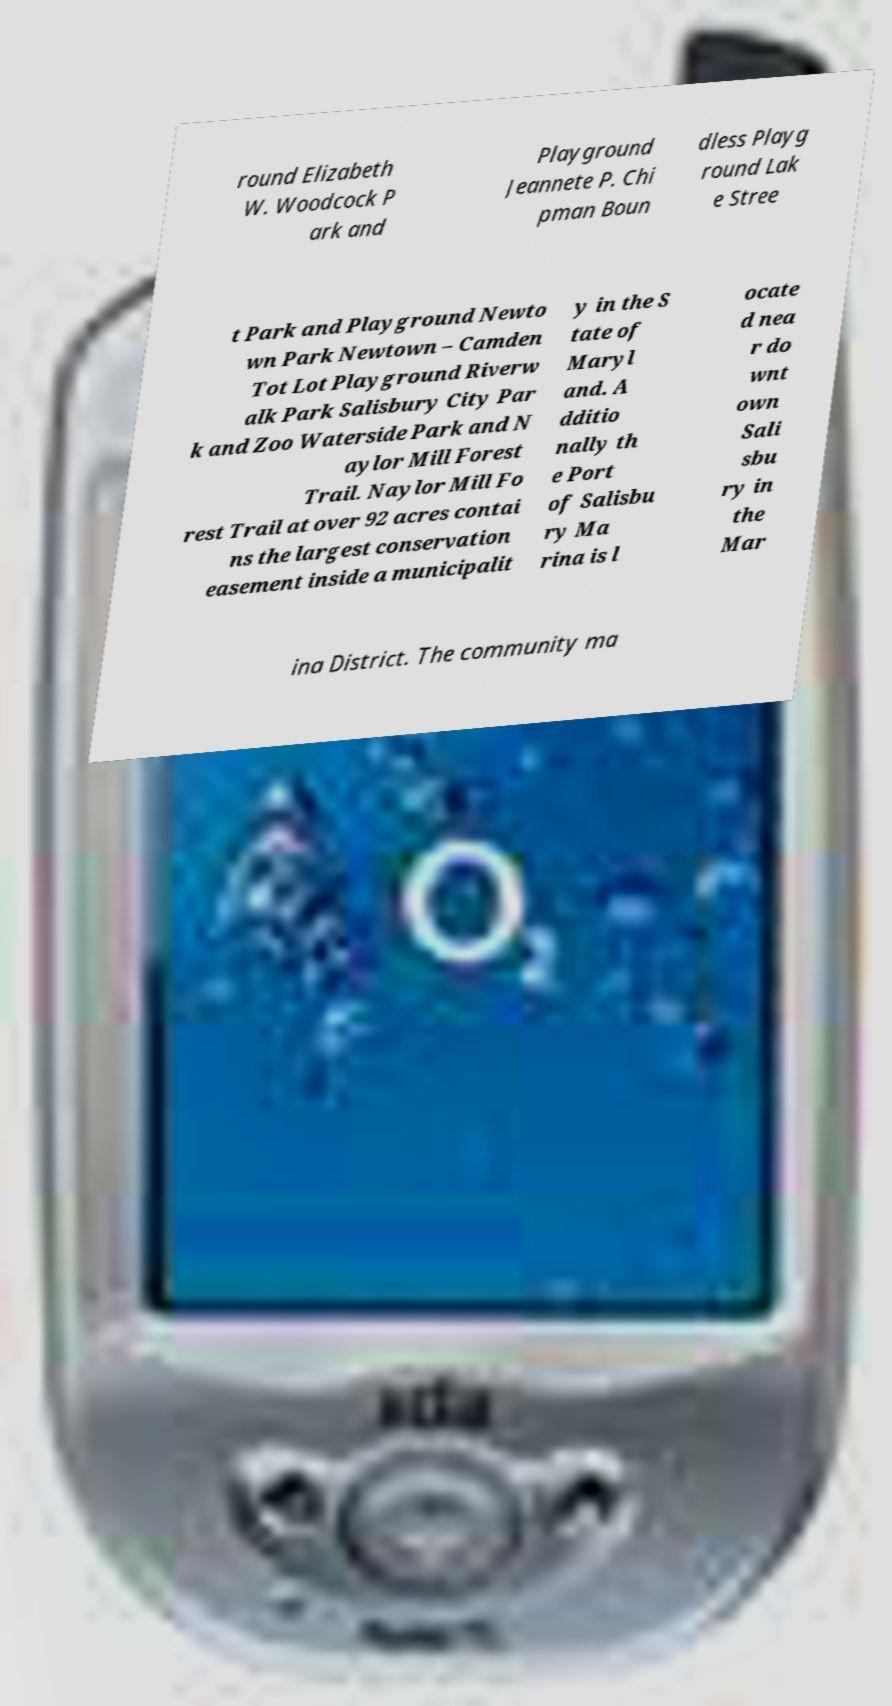Please read and relay the text visible in this image. What does it say? round Elizabeth W. Woodcock P ark and Playground Jeannete P. Chi pman Boun dless Playg round Lak e Stree t Park and Playground Newto wn Park Newtown – Camden Tot Lot Playground Riverw alk Park Salisbury City Par k and Zoo Waterside Park and N aylor Mill Forest Trail. Naylor Mill Fo rest Trail at over 92 acres contai ns the largest conservation easement inside a municipalit y in the S tate of Maryl and. A dditio nally th e Port of Salisbu ry Ma rina is l ocate d nea r do wnt own Sali sbu ry in the Mar ina District. The community ma 